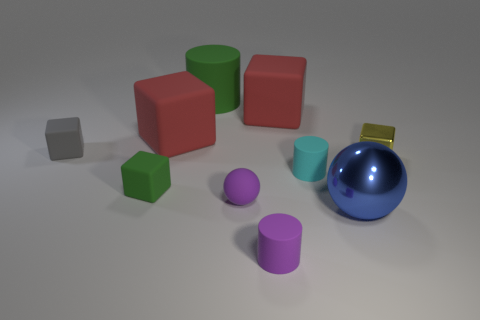Subtract all gray cubes. How many cubes are left? 4 Subtract all yellow metal cubes. How many cubes are left? 4 Subtract all purple cubes. Subtract all brown balls. How many cubes are left? 5 Subtract all cylinders. How many objects are left? 7 Subtract 0 yellow spheres. How many objects are left? 10 Subtract all large cubes. Subtract all yellow objects. How many objects are left? 7 Add 6 big matte cylinders. How many big matte cylinders are left? 7 Add 3 blue metallic spheres. How many blue metallic spheres exist? 4 